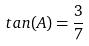Convert formula to latex. <formula><loc_0><loc_0><loc_500><loc_500>t a n ( A ) = \frac { 3 } { 7 }</formula> 